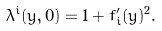<formula> <loc_0><loc_0><loc_500><loc_500>\lambda ^ { i } ( y , 0 ) = 1 + f _ { i } ^ { \prime } ( y ) ^ { 2 } .</formula> 